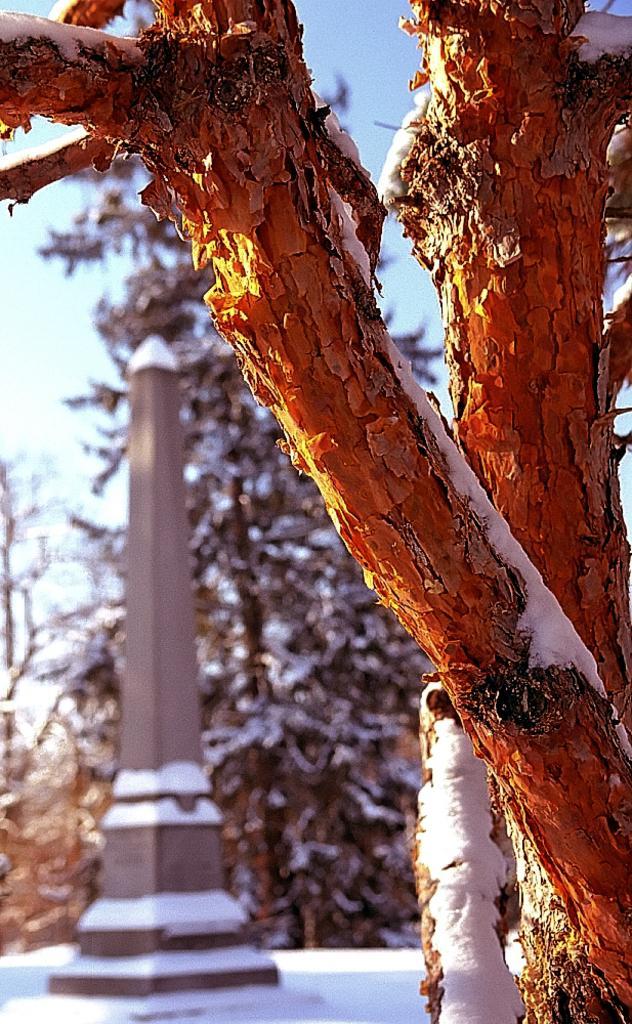Can you describe this image briefly? In this picture I can see 2 trunks in front, on which there is snow. In the background I can see the trees and a pillar and I see these things are covered with snow and I can see the sky. 